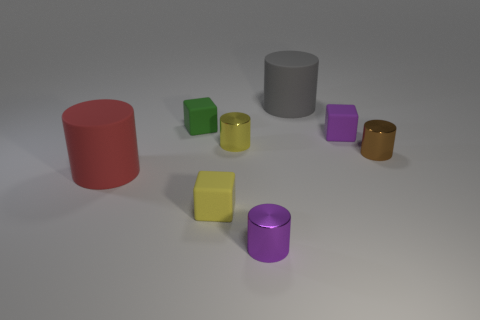Subtract all yellow cylinders. How many cylinders are left? 4 Subtract all blue cylinders. Subtract all purple spheres. How many cylinders are left? 5 Add 1 tiny metallic objects. How many objects exist? 9 Subtract all cylinders. How many objects are left? 3 Add 8 gray matte cylinders. How many gray matte cylinders are left? 9 Add 7 tiny gray metal blocks. How many tiny gray metal blocks exist? 7 Subtract 1 yellow cubes. How many objects are left? 7 Subtract all purple cylinders. Subtract all big gray objects. How many objects are left? 6 